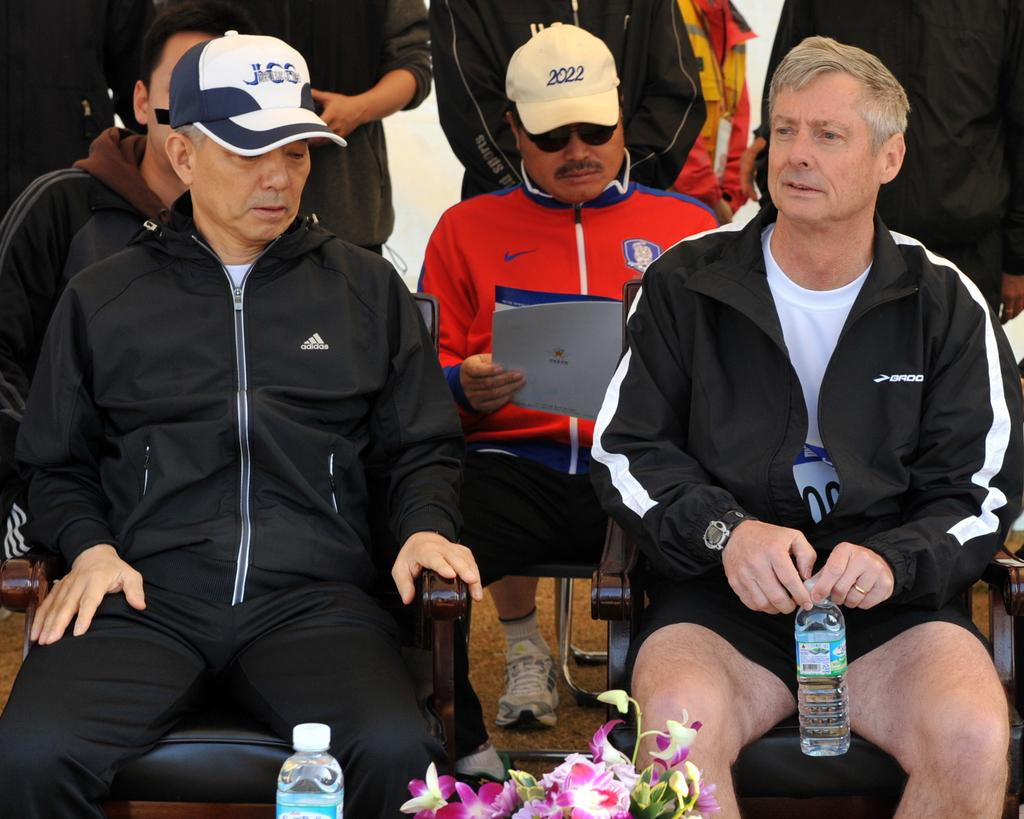<image>
Provide a brief description of the given image. A man wearing a JCS hat sits in a track suit. 